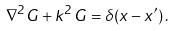Convert formula to latex. <formula><loc_0><loc_0><loc_500><loc_500>\nabla ^ { 2 } G + k ^ { 2 } \, G = \delta ( { x } - { x } ^ { \prime } ) \, .</formula> 